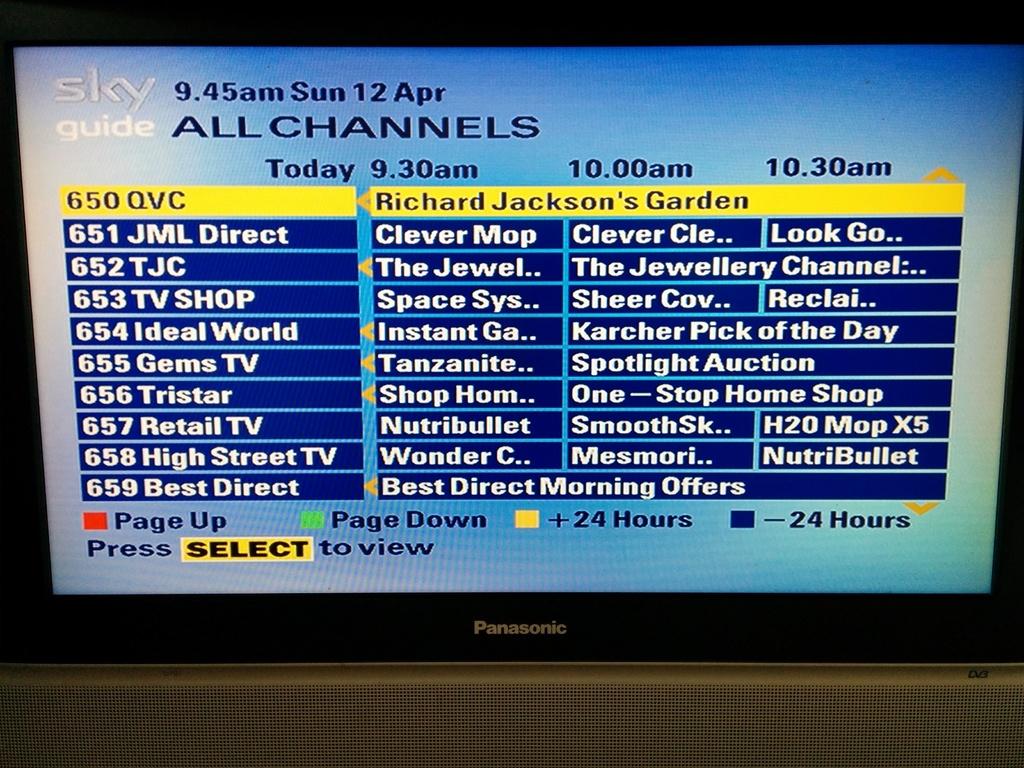What day of the week was it here?
Your answer should be very brief. Sunday. What month was this?
Make the answer very short. April. 